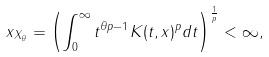Convert formula to latex. <formula><loc_0><loc_0><loc_500><loc_500>\| x \| _ { X _ { \theta } } = \left ( \int _ { 0 } ^ { \infty } t ^ { \theta p - 1 } K ( t , x ) ^ { p } d t \right ) ^ { \frac { 1 } { p } } < \infty ,</formula> 